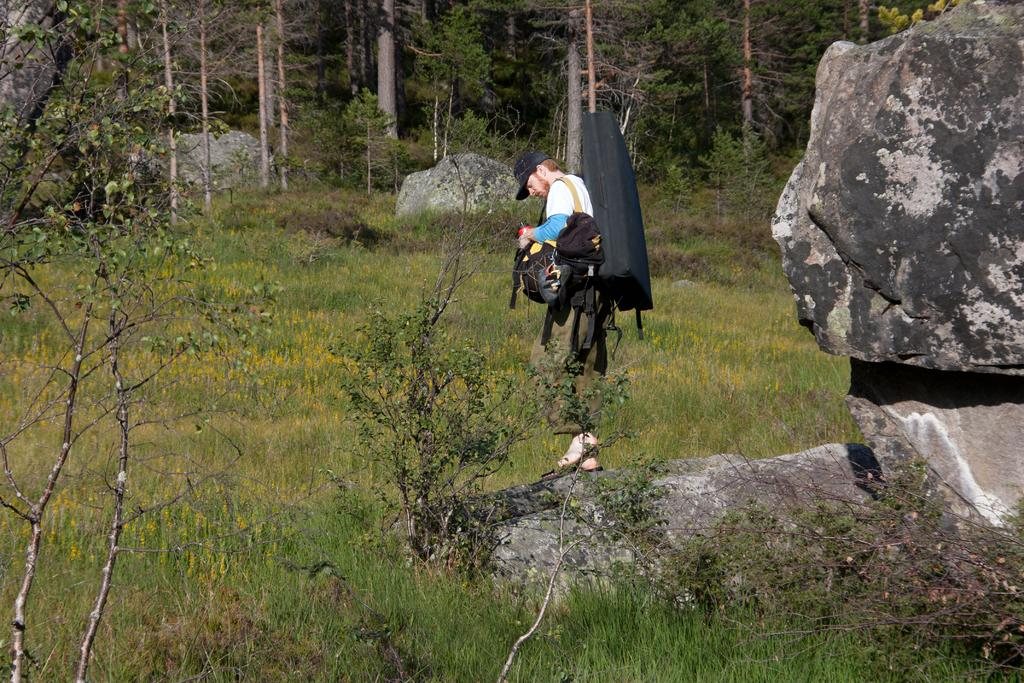What is the person in the image doing? The person is standing in the image and holding bags. What type of terrain is visible in the image? There is grass, trees with branches and leaves, and rocks in the image. Can you describe the person's surroundings? The person is surrounded by grass, trees, and rocks. How many fingers can be seen holding the toys in the image? There are no toys or fingers visible in the image; it only shows a person standing with bags and the surrounding terrain. 